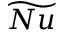<formula> <loc_0><loc_0><loc_500><loc_500>\widetilde { N u }</formula> 